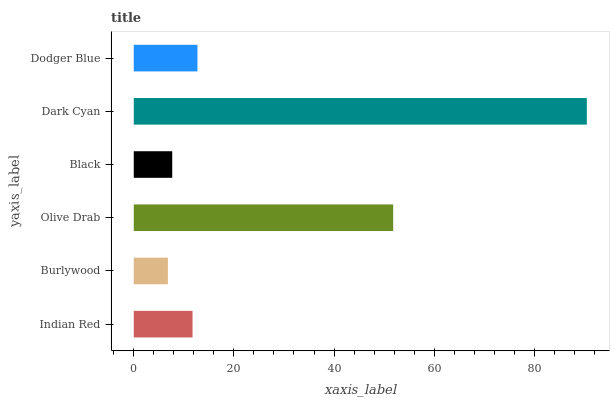Is Burlywood the minimum?
Answer yes or no. Yes. Is Dark Cyan the maximum?
Answer yes or no. Yes. Is Olive Drab the minimum?
Answer yes or no. No. Is Olive Drab the maximum?
Answer yes or no. No. Is Olive Drab greater than Burlywood?
Answer yes or no. Yes. Is Burlywood less than Olive Drab?
Answer yes or no. Yes. Is Burlywood greater than Olive Drab?
Answer yes or no. No. Is Olive Drab less than Burlywood?
Answer yes or no. No. Is Dodger Blue the high median?
Answer yes or no. Yes. Is Indian Red the low median?
Answer yes or no. Yes. Is Indian Red the high median?
Answer yes or no. No. Is Burlywood the low median?
Answer yes or no. No. 